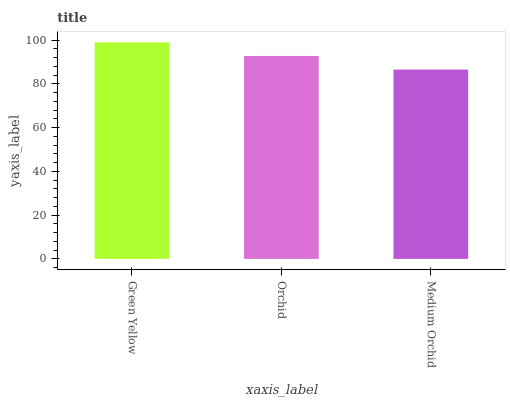Is Medium Orchid the minimum?
Answer yes or no. Yes. Is Green Yellow the maximum?
Answer yes or no. Yes. Is Orchid the minimum?
Answer yes or no. No. Is Orchid the maximum?
Answer yes or no. No. Is Green Yellow greater than Orchid?
Answer yes or no. Yes. Is Orchid less than Green Yellow?
Answer yes or no. Yes. Is Orchid greater than Green Yellow?
Answer yes or no. No. Is Green Yellow less than Orchid?
Answer yes or no. No. Is Orchid the high median?
Answer yes or no. Yes. Is Orchid the low median?
Answer yes or no. Yes. Is Green Yellow the high median?
Answer yes or no. No. Is Medium Orchid the low median?
Answer yes or no. No. 